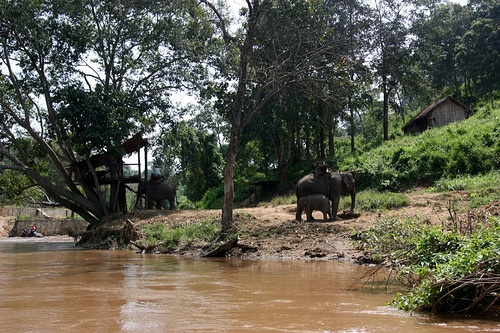Describe the objects in this image and their specific colors. I can see elephant in darkgreen, black, gray, and darkgray tones, elephant in darkgreen, black, and gray tones, and elephant in darkgreen, black, and gray tones in this image. 